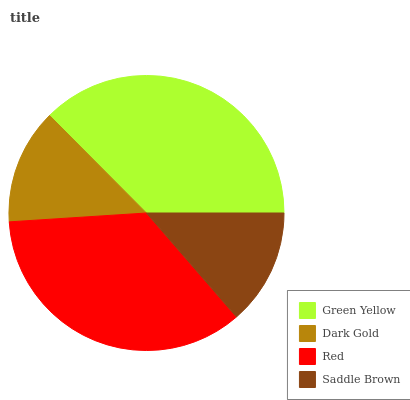Is Dark Gold the minimum?
Answer yes or no. Yes. Is Green Yellow the maximum?
Answer yes or no. Yes. Is Red the minimum?
Answer yes or no. No. Is Red the maximum?
Answer yes or no. No. Is Red greater than Dark Gold?
Answer yes or no. Yes. Is Dark Gold less than Red?
Answer yes or no. Yes. Is Dark Gold greater than Red?
Answer yes or no. No. Is Red less than Dark Gold?
Answer yes or no. No. Is Red the high median?
Answer yes or no. Yes. Is Saddle Brown the low median?
Answer yes or no. Yes. Is Dark Gold the high median?
Answer yes or no. No. Is Dark Gold the low median?
Answer yes or no. No. 